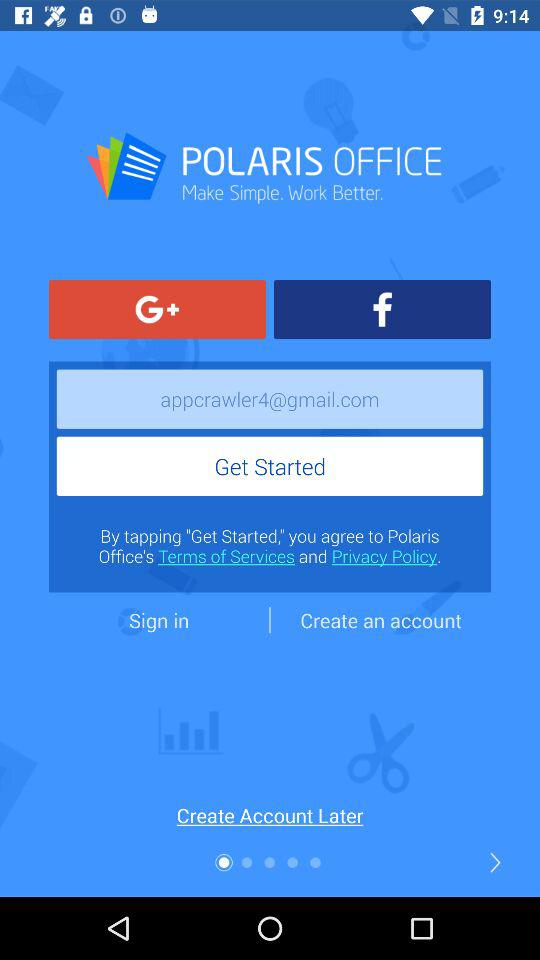Which applications can we use to log in? You can use "Google+" and "Facebook" to log in. 